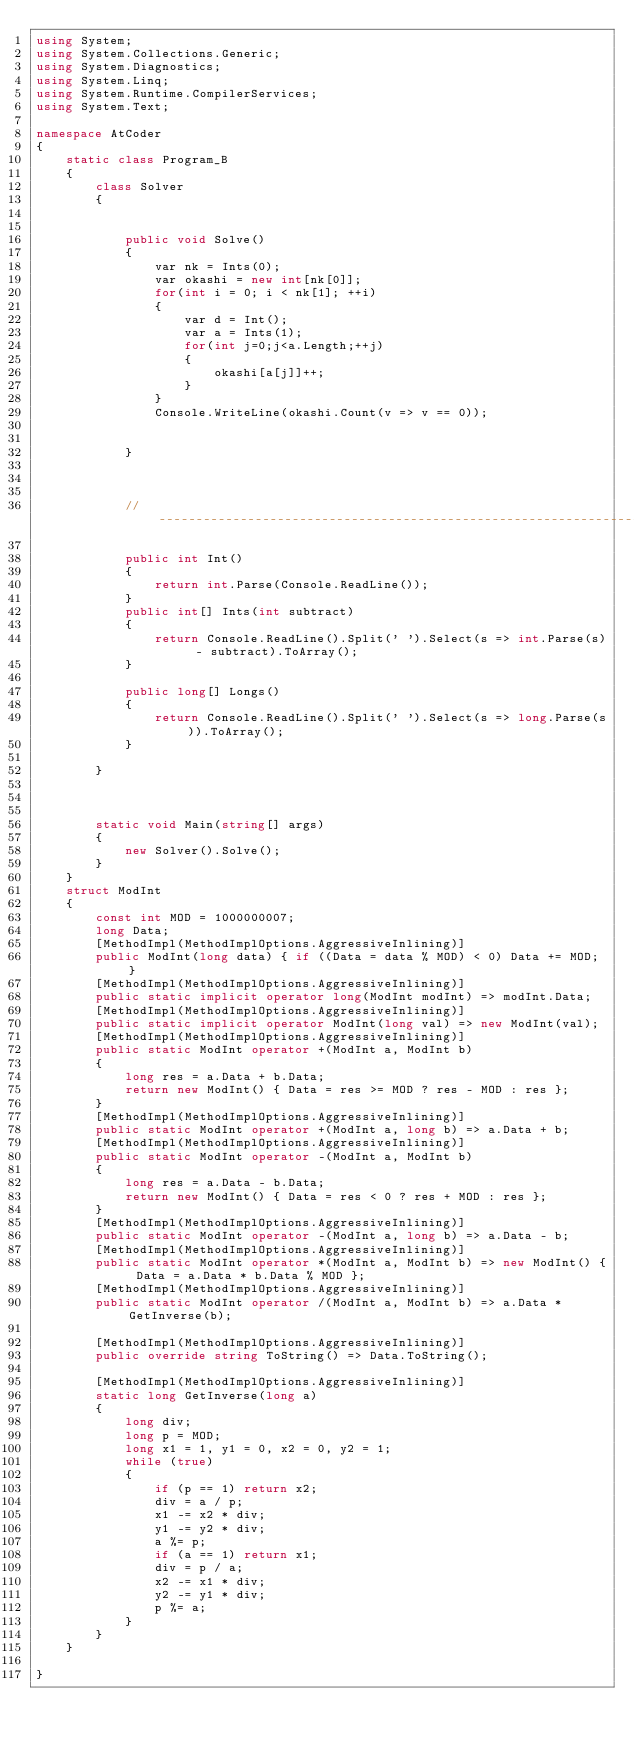<code> <loc_0><loc_0><loc_500><loc_500><_C#_>using System;
using System.Collections.Generic;
using System.Diagnostics;
using System.Linq;
using System.Runtime.CompilerServices;
using System.Text;

namespace AtCoder
{
    static class Program_B
    {
        class Solver
        {


            public void Solve()
            {
                var nk = Ints(0);
                var okashi = new int[nk[0]];
                for(int i = 0; i < nk[1]; ++i)
                {
                    var d = Int();
                    var a = Ints(1);
                    for(int j=0;j<a.Length;++j)
                    {
                        okashi[a[j]]++;
                    }
                }
                Console.WriteLine(okashi.Count(v => v == 0));


            }



            // ----------------------------------------------------------------------------

            public int Int()
            {
                return int.Parse(Console.ReadLine());
            }
            public int[] Ints(int subtract)
            {
                return Console.ReadLine().Split(' ').Select(s => int.Parse(s) - subtract).ToArray();
            }

            public long[] Longs()
            {
                return Console.ReadLine().Split(' ').Select(s => long.Parse(s)).ToArray();
            }

        }



        static void Main(string[] args)
        {
            new Solver().Solve();
        }
    }
    struct ModInt
    {
        const int MOD = 1000000007;
        long Data;
        [MethodImpl(MethodImplOptions.AggressiveInlining)]
        public ModInt(long data) { if ((Data = data % MOD) < 0) Data += MOD; }
        [MethodImpl(MethodImplOptions.AggressiveInlining)]
        public static implicit operator long(ModInt modInt) => modInt.Data;
        [MethodImpl(MethodImplOptions.AggressiveInlining)]
        public static implicit operator ModInt(long val) => new ModInt(val);
        [MethodImpl(MethodImplOptions.AggressiveInlining)]
        public static ModInt operator +(ModInt a, ModInt b)
        {
            long res = a.Data + b.Data;
            return new ModInt() { Data = res >= MOD ? res - MOD : res };
        }
        [MethodImpl(MethodImplOptions.AggressiveInlining)]
        public static ModInt operator +(ModInt a, long b) => a.Data + b;
        [MethodImpl(MethodImplOptions.AggressiveInlining)]
        public static ModInt operator -(ModInt a, ModInt b)
        {
            long res = a.Data - b.Data;
            return new ModInt() { Data = res < 0 ? res + MOD : res };
        }
        [MethodImpl(MethodImplOptions.AggressiveInlining)]
        public static ModInt operator -(ModInt a, long b) => a.Data - b;
        [MethodImpl(MethodImplOptions.AggressiveInlining)]
        public static ModInt operator *(ModInt a, ModInt b) => new ModInt() { Data = a.Data * b.Data % MOD };
        [MethodImpl(MethodImplOptions.AggressiveInlining)]
        public static ModInt operator /(ModInt a, ModInt b) => a.Data * GetInverse(b);

        [MethodImpl(MethodImplOptions.AggressiveInlining)]
        public override string ToString() => Data.ToString();

        [MethodImpl(MethodImplOptions.AggressiveInlining)]
        static long GetInverse(long a)
        {
            long div;
            long p = MOD;
            long x1 = 1, y1 = 0, x2 = 0, y2 = 1;
            while (true)
            {
                if (p == 1) return x2;
                div = a / p;
                x1 -= x2 * div;
                y1 -= y2 * div;
                a %= p;
                if (a == 1) return x1;
                div = p / a;
                x2 -= x1 * div;
                y2 -= y1 * div;
                p %= a;
            }
        }
    }

}
</code> 